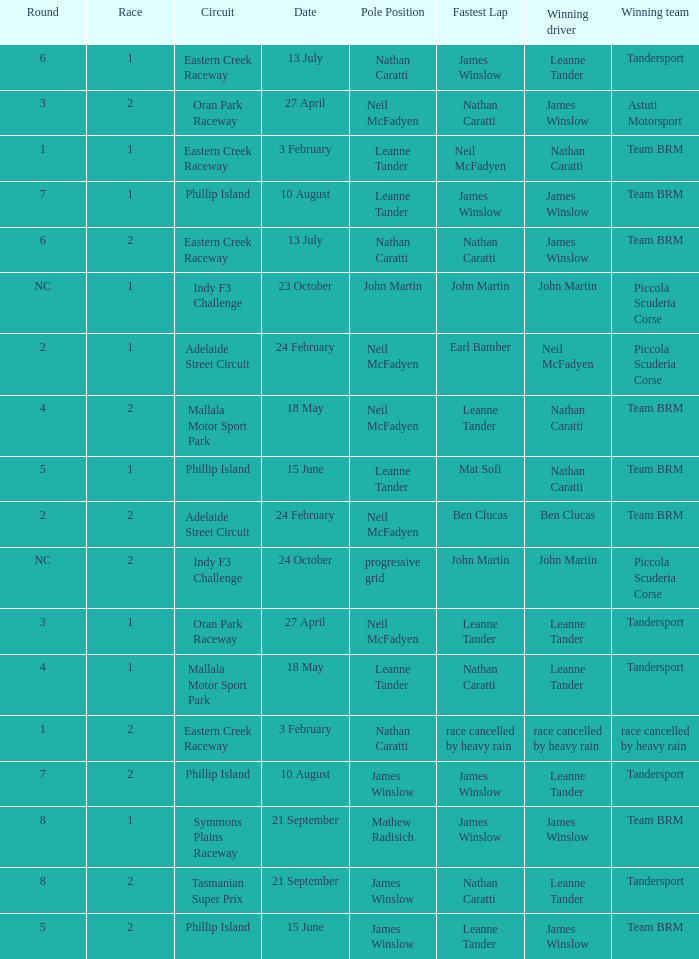Which race number featured john martin in the pole position within the indy f3 challenge circuit? 1.0. 